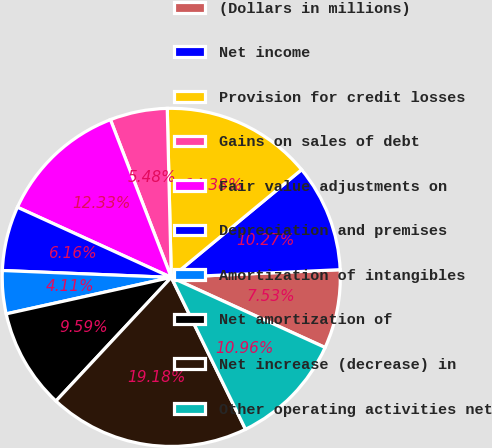<chart> <loc_0><loc_0><loc_500><loc_500><pie_chart><fcel>(Dollars in millions)<fcel>Net income<fcel>Provision for credit losses<fcel>Gains on sales of debt<fcel>Fair value adjustments on<fcel>Depreciation and premises<fcel>Amortization of intangibles<fcel>Net amortization of<fcel>Net increase (decrease) in<fcel>Other operating activities net<nl><fcel>7.53%<fcel>10.27%<fcel>14.38%<fcel>5.48%<fcel>12.33%<fcel>6.16%<fcel>4.11%<fcel>9.59%<fcel>19.18%<fcel>10.96%<nl></chart> 